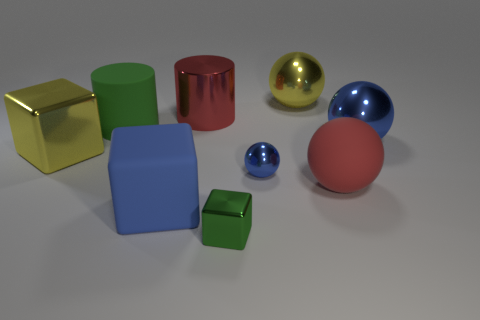Subtract all large blue metallic balls. How many balls are left? 3 Add 1 tiny green rubber objects. How many objects exist? 10 Subtract all yellow balls. How many balls are left? 3 Subtract 2 cylinders. How many cylinders are left? 0 Subtract all blue metallic spheres. Subtract all large blue matte things. How many objects are left? 6 Add 4 large yellow objects. How many large yellow objects are left? 6 Add 4 big matte objects. How many big matte objects exist? 7 Subtract 0 gray cubes. How many objects are left? 9 Subtract all cubes. How many objects are left? 6 Subtract all brown cylinders. Subtract all brown balls. How many cylinders are left? 2 